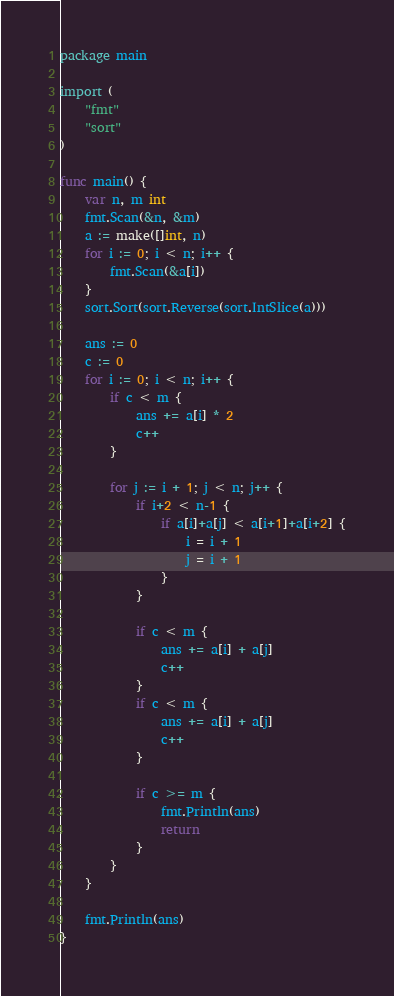<code> <loc_0><loc_0><loc_500><loc_500><_Go_>package main

import (
	"fmt"
	"sort"
)

func main() {
	var n, m int
	fmt.Scan(&n, &m)
	a := make([]int, n)
	for i := 0; i < n; i++ {
		fmt.Scan(&a[i])
	}
	sort.Sort(sort.Reverse(sort.IntSlice(a)))

	ans := 0
	c := 0
	for i := 0; i < n; i++ {
		if c < m {
			ans += a[i] * 2
			c++
		}

		for j := i + 1; j < n; j++ {
			if i+2 < n-1 {
				if a[i]+a[j] < a[i+1]+a[i+2] {
					i = i + 1
					j = i + 1
				}
			}

			if c < m {
				ans += a[i] + a[j]
				c++
			}
			if c < m {
				ans += a[i] + a[j]
				c++
			}

			if c >= m {
				fmt.Println(ans)
				return
			}
		}
	}

	fmt.Println(ans)
}
</code> 